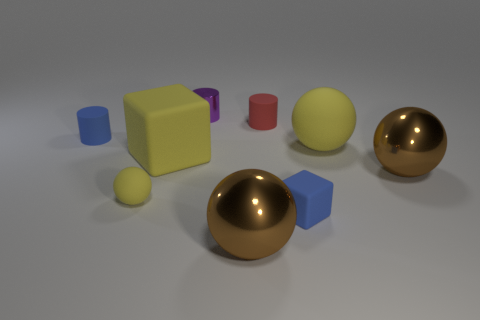Subtract all cubes. How many objects are left? 7 Add 3 tiny shiny cylinders. How many tiny shiny cylinders are left? 4 Add 6 tiny blue rubber objects. How many tiny blue rubber objects exist? 8 Subtract 2 brown balls. How many objects are left? 7 Subtract all big green rubber cylinders. Subtract all big rubber objects. How many objects are left? 7 